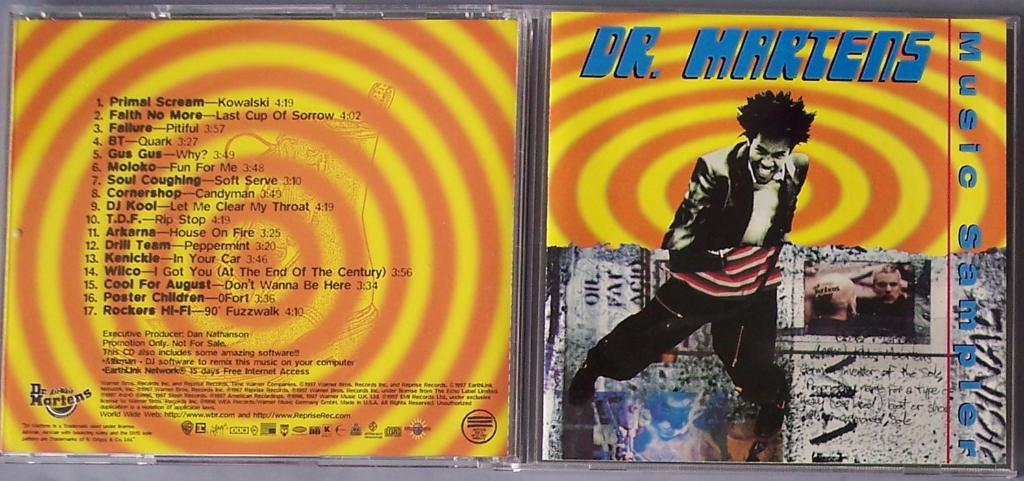<image>
Share a concise interpretation of the image provided. A plastic Dr. Martens cd cover is opened showing concentric orange and yellow circles 